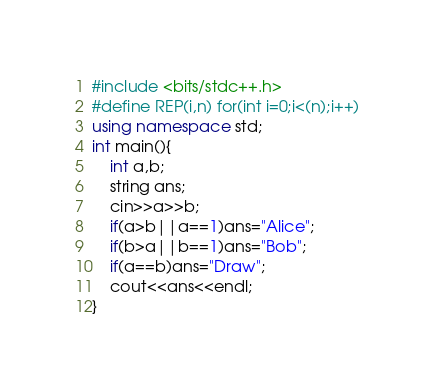Convert code to text. <code><loc_0><loc_0><loc_500><loc_500><_C++_>#include <bits/stdc++.h>
#define REP(i,n) for(int i=0;i<(n);i++)
using namespace std;
int main(){
    int a,b;
    string ans;
    cin>>a>>b;
    if(a>b||a==1)ans="Alice";
    if(b>a||b==1)ans="Bob";
    if(a==b)ans="Draw";
    cout<<ans<<endl;
}</code> 